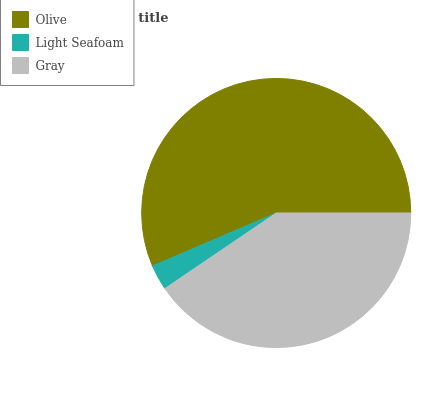Is Light Seafoam the minimum?
Answer yes or no. Yes. Is Olive the maximum?
Answer yes or no. Yes. Is Gray the minimum?
Answer yes or no. No. Is Gray the maximum?
Answer yes or no. No. Is Gray greater than Light Seafoam?
Answer yes or no. Yes. Is Light Seafoam less than Gray?
Answer yes or no. Yes. Is Light Seafoam greater than Gray?
Answer yes or no. No. Is Gray less than Light Seafoam?
Answer yes or no. No. Is Gray the high median?
Answer yes or no. Yes. Is Gray the low median?
Answer yes or no. Yes. Is Light Seafoam the high median?
Answer yes or no. No. Is Olive the low median?
Answer yes or no. No. 